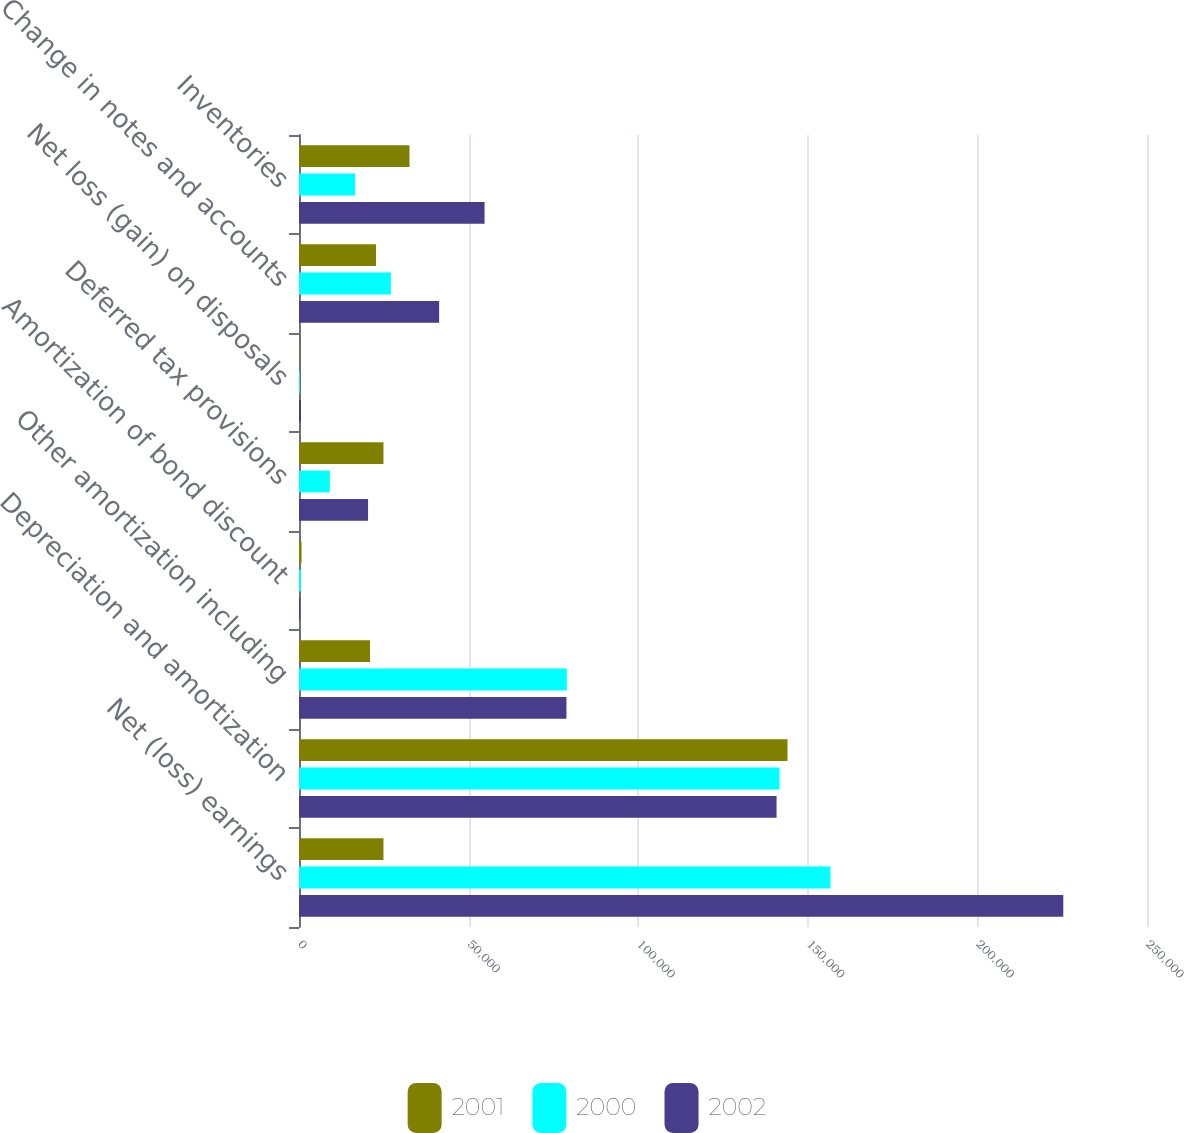Convert chart. <chart><loc_0><loc_0><loc_500><loc_500><stacked_bar_chart><ecel><fcel>Net (loss) earnings<fcel>Depreciation and amortization<fcel>Other amortization including<fcel>Amortization of bond discount<fcel>Deferred tax provisions<fcel>Net loss (gain) on disposals<fcel>Change in notes and accounts<fcel>Inventories<nl><fcel>2001<fcel>24903.5<fcel>144013<fcel>20942<fcel>744<fcel>24903.5<fcel>136<fcel>22718<fcel>32576<nl><fcel>2000<fcel>156697<fcel>141665<fcel>78951<fcel>561<fcel>9083<fcel>237<fcel>27089<fcel>16531<nl><fcel>2002<fcel>225319<fcel>140795<fcel>78846<fcel>318<fcel>20361<fcel>594<fcel>41316<fcel>54710<nl></chart> 